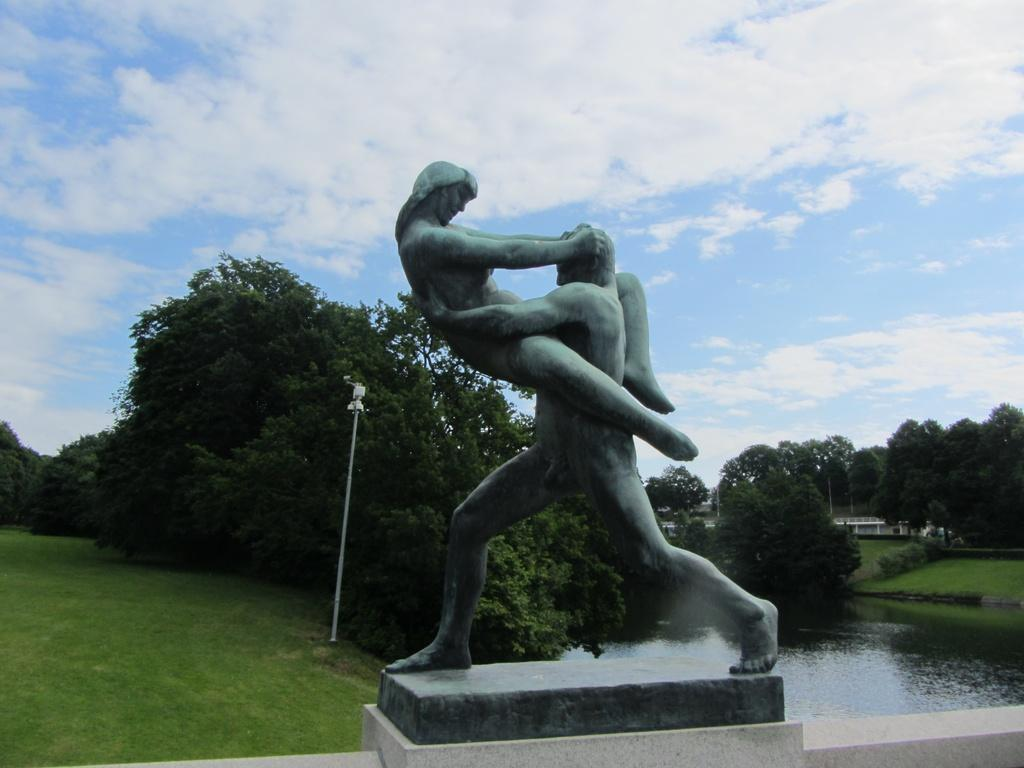What is the main subject in the image? There is a statue in the image. What type of vegetation is on the left side of the image? There is grass on the left side of the image. What is on the right side of the image? There is water on the right side of the image. What can be seen in the background of the image? There are trees and clouds in the sky in the background of the image was taken outdoors. How many sisters are playing with the trucks in the image? There are no sisters or trucks present in the image. 